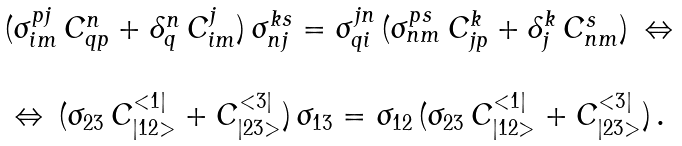<formula> <loc_0><loc_0><loc_500><loc_500>\begin{array} { c } ( \sigma ^ { p j } _ { i m } \, C ^ { n } _ { q p } + \delta ^ { n } _ { q } \, C ^ { j } _ { i m } ) \, \sigma ^ { k s } _ { n j } = \sigma ^ { j n } _ { q i } \, ( \sigma ^ { p s } _ { n m } \, C ^ { k } _ { j p } + \delta ^ { k } _ { j } \, C ^ { s } _ { n m } ) \, \Leftrightarrow \\ \\ \Leftrightarrow \, ( \sigma _ { 2 3 } \, C ^ { < 1 | } _ { | 1 2 > } + C ^ { < 3 | } _ { | 2 3 > } ) \, \sigma _ { 1 3 } = \sigma _ { 1 2 } \, ( \sigma _ { 2 3 } \, C ^ { < 1 | } _ { | 1 2 > } + C ^ { < 3 | } _ { | 2 3 > } ) \, . \end{array}</formula> 